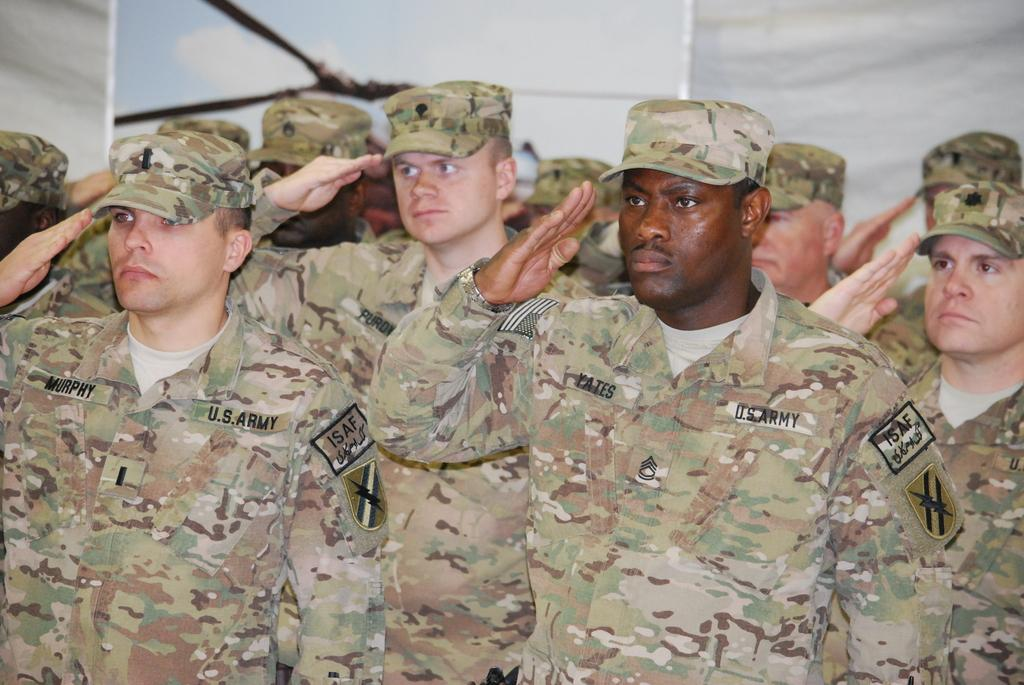What is the main subject of the image? The main subject of the image is a group of army men. What are the army men doing in the image? The army men are saluting in the image. What type of clothing are the army men wearing? The army men are wearing army dresses and caps in the image. Can you see the parent of the army men in the image? There is no parent present in the image; it features a group of army men saluting. What type of kite is being flown by the army men in the image? There is no kite present in the image; it features a group of army men saluting in their army dresses and caps. 